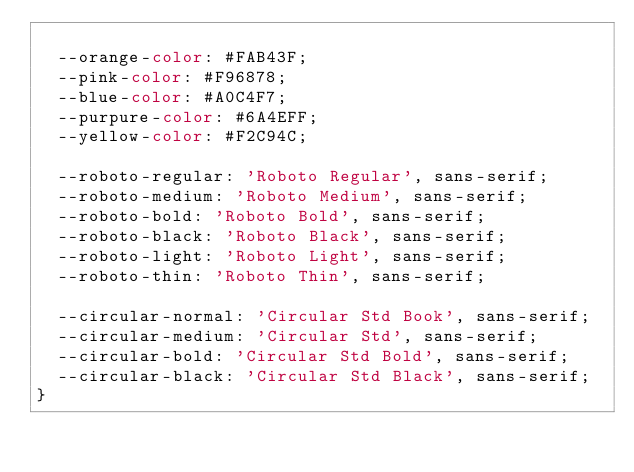Convert code to text. <code><loc_0><loc_0><loc_500><loc_500><_CSS_>
  --orange-color: #FAB43F;
  --pink-color: #F96878;
  --blue-color: #A0C4F7;
  --purpure-color: #6A4EFF;
  --yellow-color: #F2C94C;

  --roboto-regular: 'Roboto Regular', sans-serif;
  --roboto-medium: 'Roboto Medium', sans-serif;
  --roboto-bold: 'Roboto Bold', sans-serif;
  --roboto-black: 'Roboto Black', sans-serif;
  --roboto-light: 'Roboto Light', sans-serif;
  --roboto-thin: 'Roboto Thin', sans-serif;

  --circular-normal: 'Circular Std Book', sans-serif;
  --circular-medium: 'Circular Std', sans-serif;
  --circular-bold: 'Circular Std Bold', sans-serif;
  --circular-black: 'Circular Std Black', sans-serif;
}
</code> 